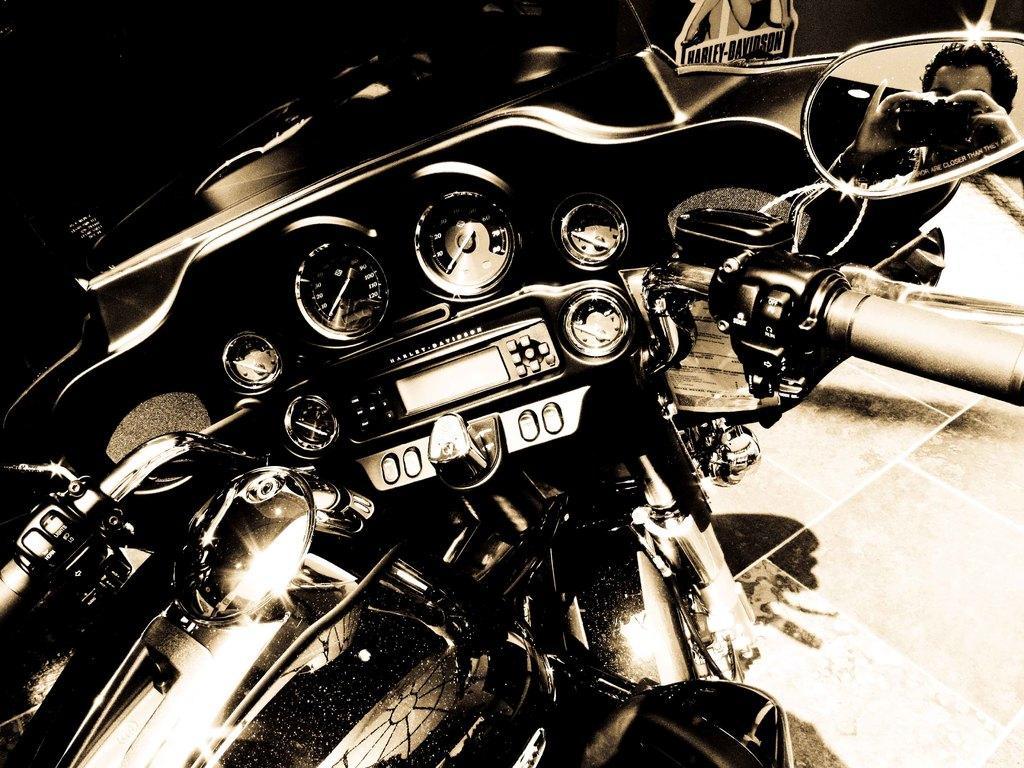How would you summarize this image in a sentence or two? In this picture I can observe a bike. On the right side I can observe a mirror. In the mirror there is a person. This is a black and white image. 